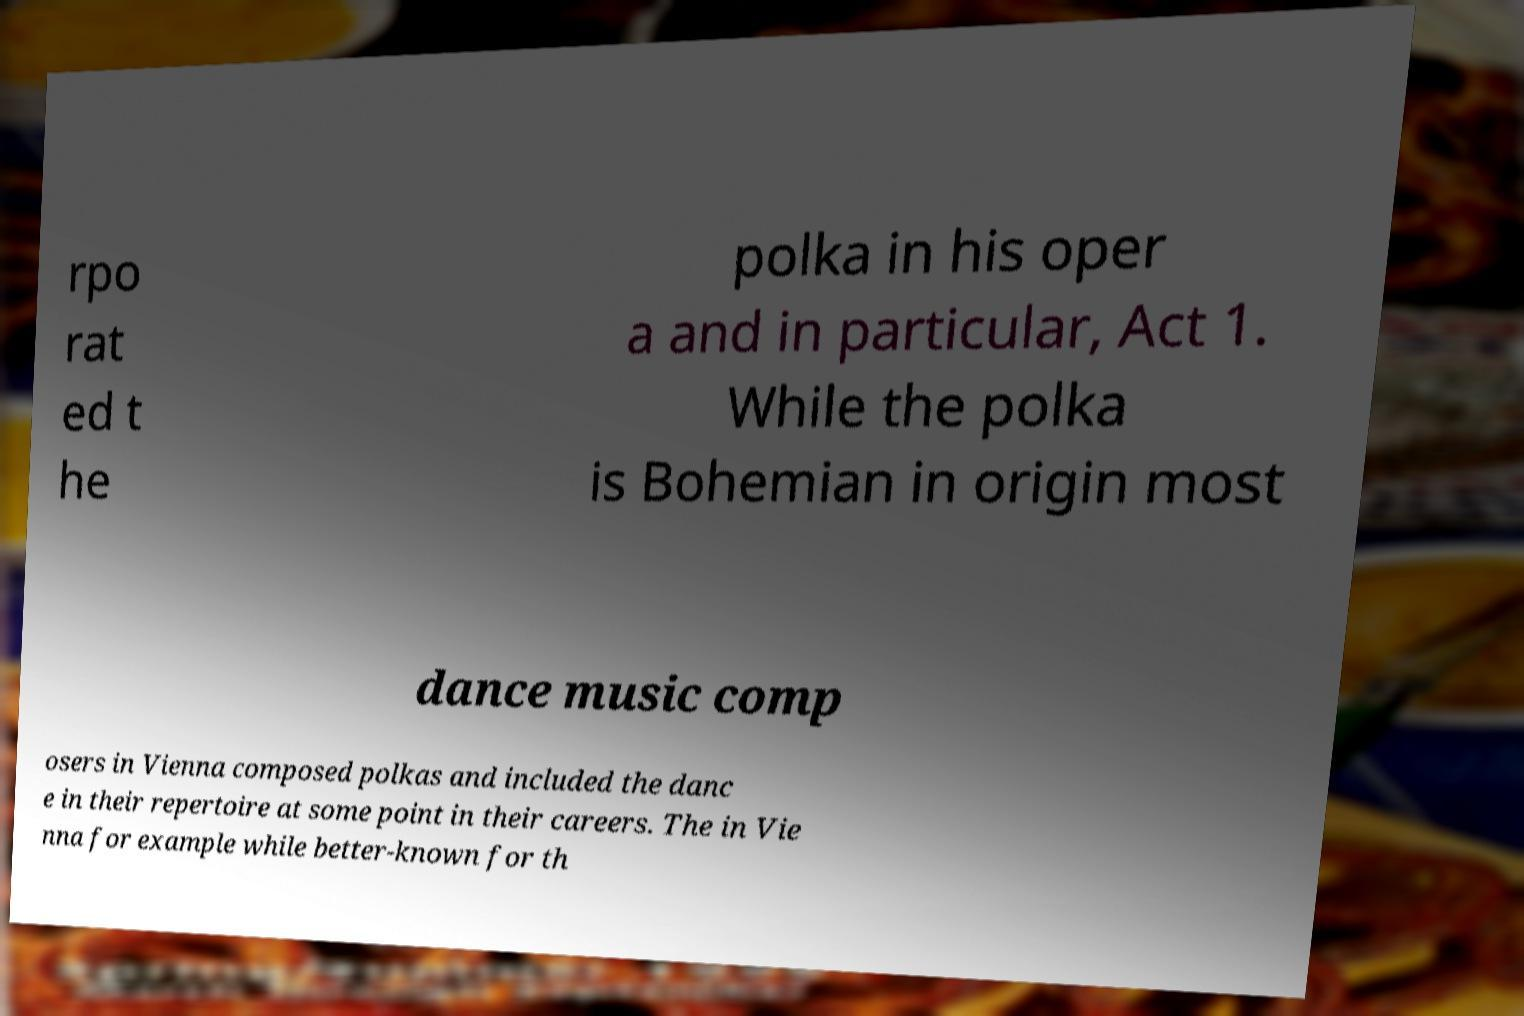There's text embedded in this image that I need extracted. Can you transcribe it verbatim? rpo rat ed t he polka in his oper a and in particular, Act 1. While the polka is Bohemian in origin most dance music comp osers in Vienna composed polkas and included the danc e in their repertoire at some point in their careers. The in Vie nna for example while better-known for th 